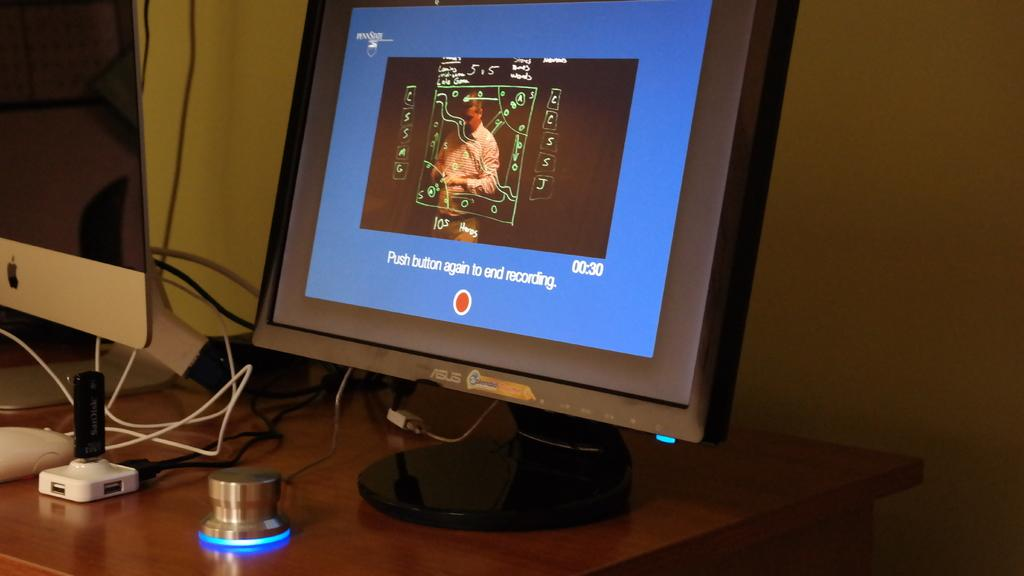<image>
Share a concise interpretation of the image provided. A computer monitor displaying a prompt to end a recording by pressing a marked button. 